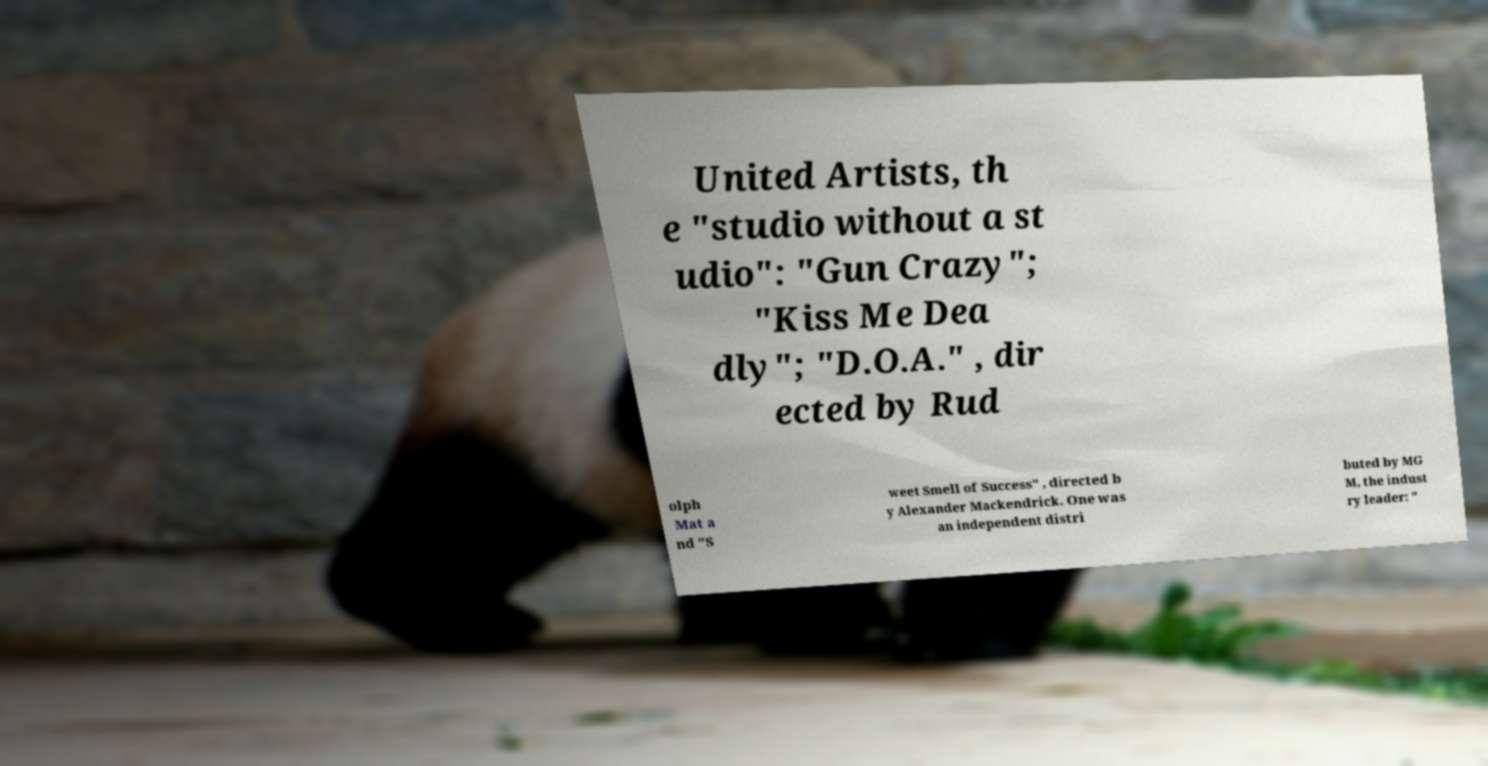I need the written content from this picture converted into text. Can you do that? United Artists, th e "studio without a st udio": "Gun Crazy"; "Kiss Me Dea dly"; "D.O.A." , dir ected by Rud olph Mat a nd "S weet Smell of Success" , directed b y Alexander Mackendrick. One was an independent distri buted by MG M, the indust ry leader: " 